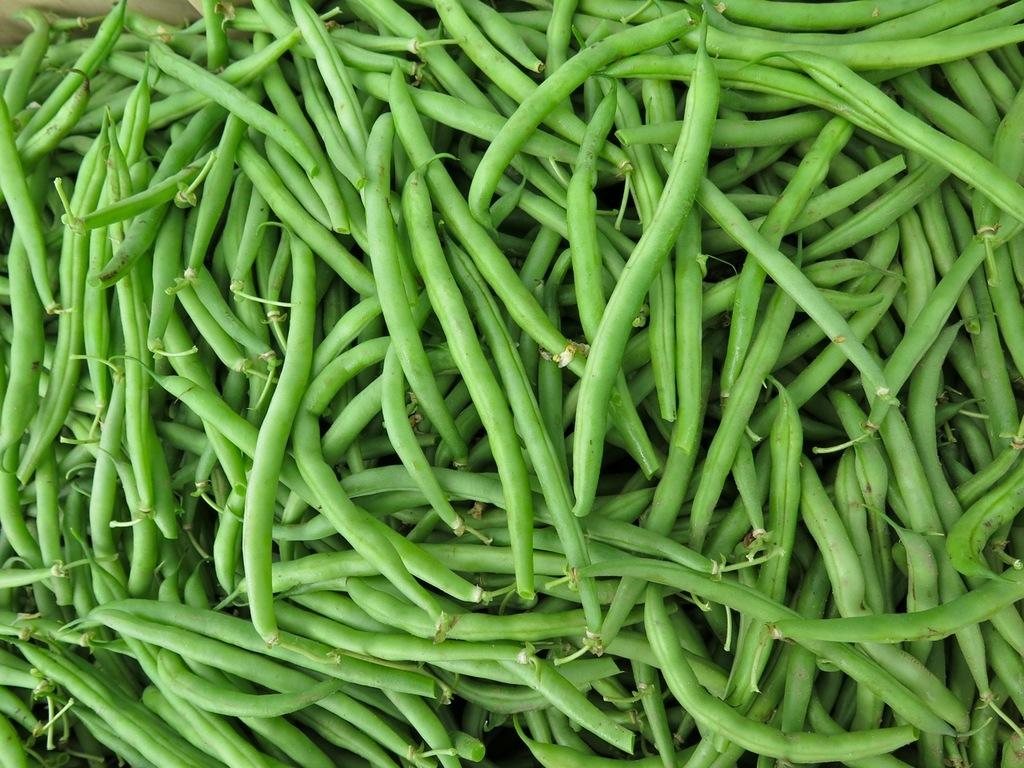What type of food can be seen in the image? There are beans in the image. What time of day is it in the image? The time of day cannot be determined from the image, as it only shows beans and does not provide any context about the time. 